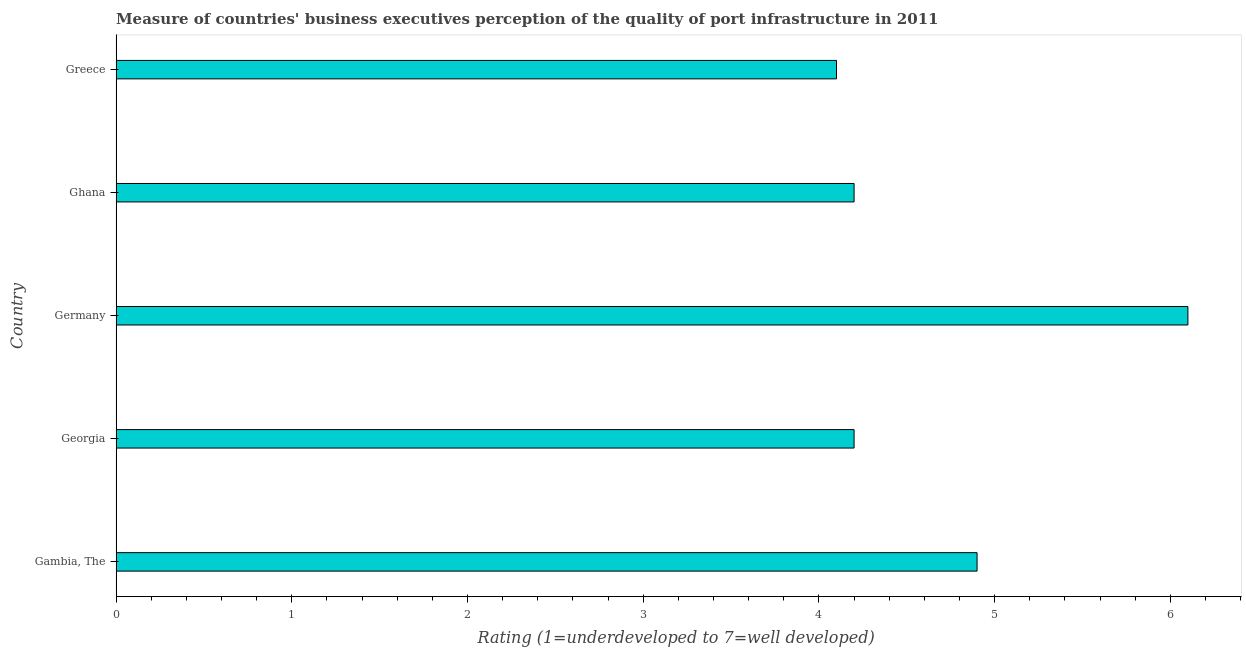Does the graph contain any zero values?
Ensure brevity in your answer.  No. Does the graph contain grids?
Give a very brief answer. No. What is the title of the graph?
Provide a succinct answer. Measure of countries' business executives perception of the quality of port infrastructure in 2011. What is the label or title of the X-axis?
Your answer should be very brief. Rating (1=underdeveloped to 7=well developed) . What is the rating measuring quality of port infrastructure in Gambia, The?
Your answer should be compact. 4.9. Across all countries, what is the minimum rating measuring quality of port infrastructure?
Give a very brief answer. 4.1. In which country was the rating measuring quality of port infrastructure minimum?
Give a very brief answer. Greece. What is the sum of the rating measuring quality of port infrastructure?
Offer a very short reply. 23.5. What is the median rating measuring quality of port infrastructure?
Keep it short and to the point. 4.2. What is the ratio of the rating measuring quality of port infrastructure in Gambia, The to that in Georgia?
Keep it short and to the point. 1.17. In how many countries, is the rating measuring quality of port infrastructure greater than the average rating measuring quality of port infrastructure taken over all countries?
Provide a short and direct response. 2. How many bars are there?
Offer a very short reply. 5. How many countries are there in the graph?
Provide a short and direct response. 5. What is the difference between two consecutive major ticks on the X-axis?
Your response must be concise. 1. What is the Rating (1=underdeveloped to 7=well developed)  in Gambia, The?
Make the answer very short. 4.9. What is the Rating (1=underdeveloped to 7=well developed)  in Georgia?
Provide a succinct answer. 4.2. What is the Rating (1=underdeveloped to 7=well developed)  of Germany?
Your response must be concise. 6.1. What is the Rating (1=underdeveloped to 7=well developed)  of Ghana?
Make the answer very short. 4.2. What is the difference between the Rating (1=underdeveloped to 7=well developed)  in Gambia, The and Georgia?
Keep it short and to the point. 0.7. What is the difference between the Rating (1=underdeveloped to 7=well developed)  in Gambia, The and Ghana?
Ensure brevity in your answer.  0.7. What is the difference between the Rating (1=underdeveloped to 7=well developed)  in Germany and Ghana?
Give a very brief answer. 1.9. What is the ratio of the Rating (1=underdeveloped to 7=well developed)  in Gambia, The to that in Georgia?
Offer a terse response. 1.17. What is the ratio of the Rating (1=underdeveloped to 7=well developed)  in Gambia, The to that in Germany?
Provide a short and direct response. 0.8. What is the ratio of the Rating (1=underdeveloped to 7=well developed)  in Gambia, The to that in Ghana?
Keep it short and to the point. 1.17. What is the ratio of the Rating (1=underdeveloped to 7=well developed)  in Gambia, The to that in Greece?
Make the answer very short. 1.2. What is the ratio of the Rating (1=underdeveloped to 7=well developed)  in Georgia to that in Germany?
Your answer should be compact. 0.69. What is the ratio of the Rating (1=underdeveloped to 7=well developed)  in Georgia to that in Ghana?
Provide a succinct answer. 1. What is the ratio of the Rating (1=underdeveloped to 7=well developed)  in Germany to that in Ghana?
Your response must be concise. 1.45. What is the ratio of the Rating (1=underdeveloped to 7=well developed)  in Germany to that in Greece?
Your response must be concise. 1.49. 